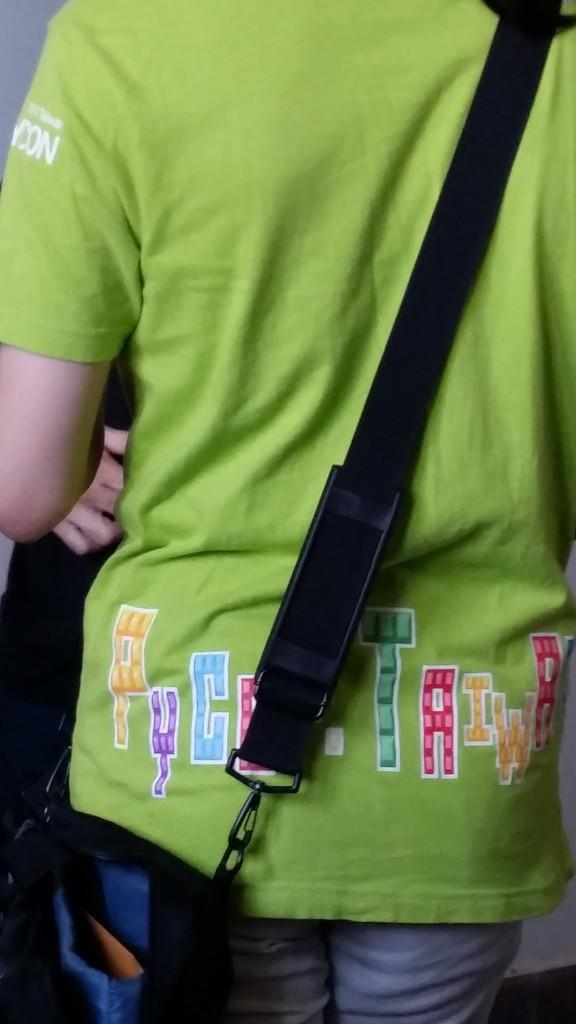What is the main subject of the image? There is a person in the image. Can you describe what the person is carrying? The person has a bag around their shoulder. What type of van can be seen in the background of the image? There is no van present in the image; it only features a person with a bag around their shoulder. What scent is emanating from the stove in the image? There is no stove present in the image, so it is not possible to determine any scent. 